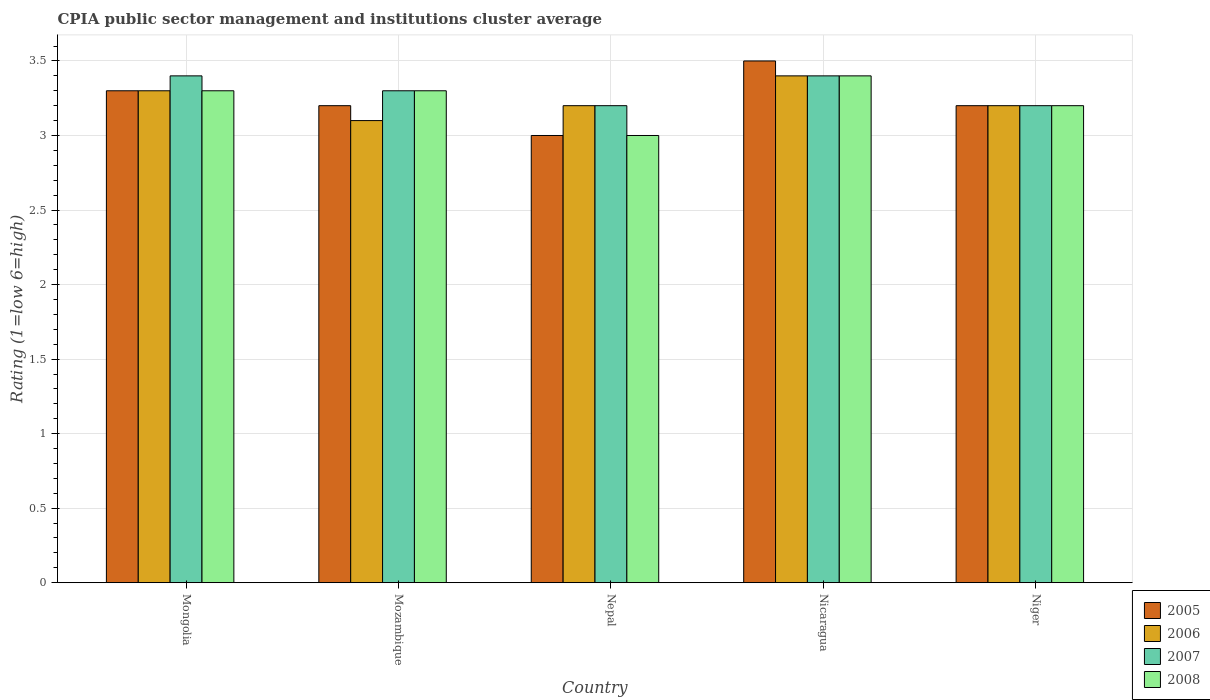Are the number of bars per tick equal to the number of legend labels?
Make the answer very short. Yes. How many bars are there on the 3rd tick from the left?
Provide a succinct answer. 4. How many bars are there on the 4th tick from the right?
Give a very brief answer. 4. What is the label of the 3rd group of bars from the left?
Your response must be concise. Nepal. What is the CPIA rating in 2008 in Mozambique?
Offer a terse response. 3.3. In which country was the CPIA rating in 2006 maximum?
Keep it short and to the point. Nicaragua. In which country was the CPIA rating in 2005 minimum?
Ensure brevity in your answer.  Nepal. What is the total CPIA rating in 2005 in the graph?
Ensure brevity in your answer.  16.2. What is the difference between the CPIA rating in 2005 in Mozambique and that in Nepal?
Offer a very short reply. 0.2. What is the difference between the CPIA rating in 2008 in Niger and the CPIA rating in 2005 in Mongolia?
Your answer should be compact. -0.1. What is the average CPIA rating in 2008 per country?
Provide a succinct answer. 3.24. What is the ratio of the CPIA rating in 2005 in Mongolia to that in Niger?
Provide a short and direct response. 1.03. Is the difference between the CPIA rating in 2008 in Mozambique and Nicaragua greater than the difference between the CPIA rating in 2007 in Mozambique and Nicaragua?
Your answer should be very brief. No. What is the difference between the highest and the second highest CPIA rating in 2008?
Offer a very short reply. -0.1. What is the difference between the highest and the lowest CPIA rating in 2006?
Offer a terse response. 0.3. In how many countries, is the CPIA rating in 2006 greater than the average CPIA rating in 2006 taken over all countries?
Offer a very short reply. 2. What does the 4th bar from the right in Niger represents?
Offer a terse response. 2005. Is it the case that in every country, the sum of the CPIA rating in 2008 and CPIA rating in 2005 is greater than the CPIA rating in 2006?
Make the answer very short. Yes. How many bars are there?
Give a very brief answer. 20. Are all the bars in the graph horizontal?
Offer a terse response. No. How many countries are there in the graph?
Your response must be concise. 5. What is the difference between two consecutive major ticks on the Y-axis?
Your answer should be very brief. 0.5. Does the graph contain any zero values?
Your answer should be compact. No. Does the graph contain grids?
Provide a succinct answer. Yes. Where does the legend appear in the graph?
Give a very brief answer. Bottom right. How many legend labels are there?
Your answer should be very brief. 4. How are the legend labels stacked?
Give a very brief answer. Vertical. What is the title of the graph?
Provide a succinct answer. CPIA public sector management and institutions cluster average. Does "2006" appear as one of the legend labels in the graph?
Offer a very short reply. Yes. What is the label or title of the Y-axis?
Your answer should be compact. Rating (1=low 6=high). What is the Rating (1=low 6=high) in 2005 in Mongolia?
Give a very brief answer. 3.3. What is the Rating (1=low 6=high) of 2006 in Mongolia?
Keep it short and to the point. 3.3. What is the Rating (1=low 6=high) in 2008 in Mongolia?
Keep it short and to the point. 3.3. What is the Rating (1=low 6=high) of 2006 in Nepal?
Provide a succinct answer. 3.2. What is the Rating (1=low 6=high) of 2007 in Nepal?
Make the answer very short. 3.2. What is the Rating (1=low 6=high) in 2005 in Nicaragua?
Your response must be concise. 3.5. What is the Rating (1=low 6=high) in 2006 in Nicaragua?
Offer a terse response. 3.4. What is the Rating (1=low 6=high) in 2007 in Nicaragua?
Your answer should be very brief. 3.4. What is the Rating (1=low 6=high) of 2008 in Nicaragua?
Make the answer very short. 3.4. What is the Rating (1=low 6=high) in 2005 in Niger?
Your answer should be very brief. 3.2. What is the Rating (1=low 6=high) in 2006 in Niger?
Provide a succinct answer. 3.2. Across all countries, what is the maximum Rating (1=low 6=high) in 2008?
Your response must be concise. 3.4. Across all countries, what is the minimum Rating (1=low 6=high) in 2005?
Provide a succinct answer. 3. Across all countries, what is the minimum Rating (1=low 6=high) in 2007?
Your response must be concise. 3.2. What is the total Rating (1=low 6=high) in 2005 in the graph?
Provide a short and direct response. 16.2. What is the total Rating (1=low 6=high) of 2007 in the graph?
Provide a succinct answer. 16.5. What is the total Rating (1=low 6=high) of 2008 in the graph?
Your answer should be compact. 16.2. What is the difference between the Rating (1=low 6=high) of 2005 in Mongolia and that in Mozambique?
Your answer should be compact. 0.1. What is the difference between the Rating (1=low 6=high) in 2006 in Mongolia and that in Mozambique?
Offer a very short reply. 0.2. What is the difference between the Rating (1=low 6=high) in 2008 in Mongolia and that in Mozambique?
Offer a terse response. 0. What is the difference between the Rating (1=low 6=high) in 2005 in Mongolia and that in Nepal?
Offer a terse response. 0.3. What is the difference between the Rating (1=low 6=high) of 2007 in Mongolia and that in Nepal?
Keep it short and to the point. 0.2. What is the difference between the Rating (1=low 6=high) of 2007 in Mongolia and that in Nicaragua?
Your response must be concise. 0. What is the difference between the Rating (1=low 6=high) in 2005 in Mongolia and that in Niger?
Ensure brevity in your answer.  0.1. What is the difference between the Rating (1=low 6=high) of 2007 in Mongolia and that in Niger?
Your response must be concise. 0.2. What is the difference between the Rating (1=low 6=high) in 2008 in Mongolia and that in Niger?
Make the answer very short. 0.1. What is the difference between the Rating (1=low 6=high) in 2005 in Mozambique and that in Nepal?
Your answer should be very brief. 0.2. What is the difference between the Rating (1=low 6=high) in 2008 in Mozambique and that in Nepal?
Make the answer very short. 0.3. What is the difference between the Rating (1=low 6=high) of 2005 in Mozambique and that in Nicaragua?
Ensure brevity in your answer.  -0.3. What is the difference between the Rating (1=low 6=high) of 2006 in Mozambique and that in Nicaragua?
Keep it short and to the point. -0.3. What is the difference between the Rating (1=low 6=high) in 2007 in Mozambique and that in Nicaragua?
Offer a terse response. -0.1. What is the difference between the Rating (1=low 6=high) in 2008 in Mozambique and that in Nicaragua?
Make the answer very short. -0.1. What is the difference between the Rating (1=low 6=high) of 2005 in Mozambique and that in Niger?
Give a very brief answer. 0. What is the difference between the Rating (1=low 6=high) in 2007 in Mozambique and that in Niger?
Your response must be concise. 0.1. What is the difference between the Rating (1=low 6=high) in 2008 in Mozambique and that in Niger?
Your answer should be very brief. 0.1. What is the difference between the Rating (1=low 6=high) in 2005 in Nepal and that in Nicaragua?
Your answer should be very brief. -0.5. What is the difference between the Rating (1=low 6=high) of 2006 in Nepal and that in Nicaragua?
Offer a terse response. -0.2. What is the difference between the Rating (1=low 6=high) in 2008 in Nepal and that in Nicaragua?
Offer a very short reply. -0.4. What is the difference between the Rating (1=low 6=high) in 2005 in Nepal and that in Niger?
Provide a succinct answer. -0.2. What is the difference between the Rating (1=low 6=high) in 2007 in Nepal and that in Niger?
Your answer should be very brief. 0. What is the difference between the Rating (1=low 6=high) in 2008 in Nepal and that in Niger?
Provide a short and direct response. -0.2. What is the difference between the Rating (1=low 6=high) of 2005 in Nicaragua and that in Niger?
Offer a terse response. 0.3. What is the difference between the Rating (1=low 6=high) of 2006 in Nicaragua and that in Niger?
Your response must be concise. 0.2. What is the difference between the Rating (1=low 6=high) in 2008 in Nicaragua and that in Niger?
Keep it short and to the point. 0.2. What is the difference between the Rating (1=low 6=high) in 2005 in Mongolia and the Rating (1=low 6=high) in 2006 in Mozambique?
Your answer should be very brief. 0.2. What is the difference between the Rating (1=low 6=high) of 2005 in Mongolia and the Rating (1=low 6=high) of 2008 in Mozambique?
Give a very brief answer. 0. What is the difference between the Rating (1=low 6=high) of 2006 in Mongolia and the Rating (1=low 6=high) of 2007 in Mozambique?
Offer a terse response. 0. What is the difference between the Rating (1=low 6=high) of 2006 in Mongolia and the Rating (1=low 6=high) of 2008 in Mozambique?
Provide a succinct answer. 0. What is the difference between the Rating (1=low 6=high) in 2005 in Mongolia and the Rating (1=low 6=high) in 2006 in Nepal?
Provide a short and direct response. 0.1. What is the difference between the Rating (1=low 6=high) of 2005 in Mongolia and the Rating (1=low 6=high) of 2007 in Nepal?
Provide a succinct answer. 0.1. What is the difference between the Rating (1=low 6=high) in 2005 in Mongolia and the Rating (1=low 6=high) in 2008 in Nepal?
Ensure brevity in your answer.  0.3. What is the difference between the Rating (1=low 6=high) in 2006 in Mongolia and the Rating (1=low 6=high) in 2007 in Nepal?
Offer a very short reply. 0.1. What is the difference between the Rating (1=low 6=high) of 2006 in Mongolia and the Rating (1=low 6=high) of 2008 in Nepal?
Make the answer very short. 0.3. What is the difference between the Rating (1=low 6=high) in 2007 in Mongolia and the Rating (1=low 6=high) in 2008 in Nepal?
Offer a very short reply. 0.4. What is the difference between the Rating (1=low 6=high) in 2005 in Mongolia and the Rating (1=low 6=high) in 2006 in Nicaragua?
Your answer should be compact. -0.1. What is the difference between the Rating (1=low 6=high) in 2005 in Mongolia and the Rating (1=low 6=high) in 2007 in Nicaragua?
Your answer should be very brief. -0.1. What is the difference between the Rating (1=low 6=high) of 2006 in Mongolia and the Rating (1=low 6=high) of 2007 in Nicaragua?
Your answer should be compact. -0.1. What is the difference between the Rating (1=low 6=high) of 2007 in Mongolia and the Rating (1=low 6=high) of 2008 in Nicaragua?
Make the answer very short. 0. What is the difference between the Rating (1=low 6=high) of 2005 in Mongolia and the Rating (1=low 6=high) of 2006 in Niger?
Provide a short and direct response. 0.1. What is the difference between the Rating (1=low 6=high) in 2005 in Mongolia and the Rating (1=low 6=high) in 2008 in Niger?
Provide a succinct answer. 0.1. What is the difference between the Rating (1=low 6=high) of 2006 in Mongolia and the Rating (1=low 6=high) of 2007 in Niger?
Your response must be concise. 0.1. What is the difference between the Rating (1=low 6=high) in 2006 in Mongolia and the Rating (1=low 6=high) in 2008 in Niger?
Give a very brief answer. 0.1. What is the difference between the Rating (1=low 6=high) in 2007 in Mongolia and the Rating (1=low 6=high) in 2008 in Niger?
Ensure brevity in your answer.  0.2. What is the difference between the Rating (1=low 6=high) of 2005 in Mozambique and the Rating (1=low 6=high) of 2006 in Nepal?
Give a very brief answer. 0. What is the difference between the Rating (1=low 6=high) in 2005 in Mozambique and the Rating (1=low 6=high) in 2007 in Nepal?
Your answer should be very brief. 0. What is the difference between the Rating (1=low 6=high) of 2006 in Mozambique and the Rating (1=low 6=high) of 2007 in Nepal?
Give a very brief answer. -0.1. What is the difference between the Rating (1=low 6=high) in 2006 in Mozambique and the Rating (1=low 6=high) in 2008 in Nepal?
Your response must be concise. 0.1. What is the difference between the Rating (1=low 6=high) of 2005 in Mozambique and the Rating (1=low 6=high) of 2007 in Nicaragua?
Ensure brevity in your answer.  -0.2. What is the difference between the Rating (1=low 6=high) of 2005 in Mozambique and the Rating (1=low 6=high) of 2008 in Nicaragua?
Offer a very short reply. -0.2. What is the difference between the Rating (1=low 6=high) in 2006 in Mozambique and the Rating (1=low 6=high) in 2007 in Nicaragua?
Keep it short and to the point. -0.3. What is the difference between the Rating (1=low 6=high) in 2006 in Mozambique and the Rating (1=low 6=high) in 2008 in Nicaragua?
Offer a very short reply. -0.3. What is the difference between the Rating (1=low 6=high) of 2005 in Mozambique and the Rating (1=low 6=high) of 2007 in Niger?
Offer a terse response. 0. What is the difference between the Rating (1=low 6=high) in 2005 in Mozambique and the Rating (1=low 6=high) in 2008 in Niger?
Your response must be concise. 0. What is the difference between the Rating (1=low 6=high) in 2006 in Mozambique and the Rating (1=low 6=high) in 2007 in Niger?
Offer a very short reply. -0.1. What is the difference between the Rating (1=low 6=high) of 2006 in Mozambique and the Rating (1=low 6=high) of 2008 in Niger?
Make the answer very short. -0.1. What is the difference between the Rating (1=low 6=high) of 2007 in Mozambique and the Rating (1=low 6=high) of 2008 in Niger?
Your answer should be compact. 0.1. What is the difference between the Rating (1=low 6=high) in 2005 in Nepal and the Rating (1=low 6=high) in 2006 in Nicaragua?
Provide a short and direct response. -0.4. What is the difference between the Rating (1=low 6=high) in 2005 in Nepal and the Rating (1=low 6=high) in 2008 in Nicaragua?
Ensure brevity in your answer.  -0.4. What is the difference between the Rating (1=low 6=high) of 2006 in Nepal and the Rating (1=low 6=high) of 2007 in Nicaragua?
Give a very brief answer. -0.2. What is the difference between the Rating (1=low 6=high) in 2006 in Nepal and the Rating (1=low 6=high) in 2008 in Nicaragua?
Your answer should be compact. -0.2. What is the difference between the Rating (1=low 6=high) in 2005 in Nepal and the Rating (1=low 6=high) in 2006 in Niger?
Your answer should be compact. -0.2. What is the difference between the Rating (1=low 6=high) of 2006 in Nepal and the Rating (1=low 6=high) of 2008 in Niger?
Your answer should be very brief. 0. What is the difference between the Rating (1=low 6=high) of 2007 in Nepal and the Rating (1=low 6=high) of 2008 in Niger?
Offer a very short reply. 0. What is the difference between the Rating (1=low 6=high) in 2005 in Nicaragua and the Rating (1=low 6=high) in 2008 in Niger?
Provide a succinct answer. 0.3. What is the difference between the Rating (1=low 6=high) of 2006 in Nicaragua and the Rating (1=low 6=high) of 2007 in Niger?
Make the answer very short. 0.2. What is the difference between the Rating (1=low 6=high) of 2006 in Nicaragua and the Rating (1=low 6=high) of 2008 in Niger?
Your answer should be compact. 0.2. What is the difference between the Rating (1=low 6=high) of 2007 in Nicaragua and the Rating (1=low 6=high) of 2008 in Niger?
Your answer should be compact. 0.2. What is the average Rating (1=low 6=high) of 2005 per country?
Ensure brevity in your answer.  3.24. What is the average Rating (1=low 6=high) in 2006 per country?
Give a very brief answer. 3.24. What is the average Rating (1=low 6=high) of 2007 per country?
Provide a succinct answer. 3.3. What is the average Rating (1=low 6=high) in 2008 per country?
Make the answer very short. 3.24. What is the difference between the Rating (1=low 6=high) of 2005 and Rating (1=low 6=high) of 2006 in Mongolia?
Make the answer very short. 0. What is the difference between the Rating (1=low 6=high) in 2005 and Rating (1=low 6=high) in 2007 in Mongolia?
Make the answer very short. -0.1. What is the difference between the Rating (1=low 6=high) in 2006 and Rating (1=low 6=high) in 2008 in Mongolia?
Your response must be concise. 0. What is the difference between the Rating (1=low 6=high) in 2007 and Rating (1=low 6=high) in 2008 in Mongolia?
Your answer should be compact. 0.1. What is the difference between the Rating (1=low 6=high) in 2005 and Rating (1=low 6=high) in 2008 in Mozambique?
Provide a succinct answer. -0.1. What is the difference between the Rating (1=low 6=high) of 2006 and Rating (1=low 6=high) of 2007 in Mozambique?
Offer a terse response. -0.2. What is the difference between the Rating (1=low 6=high) of 2007 and Rating (1=low 6=high) of 2008 in Mozambique?
Provide a succinct answer. 0. What is the difference between the Rating (1=low 6=high) in 2006 and Rating (1=low 6=high) in 2007 in Nepal?
Give a very brief answer. 0. What is the difference between the Rating (1=low 6=high) of 2006 and Rating (1=low 6=high) of 2008 in Nepal?
Ensure brevity in your answer.  0.2. What is the difference between the Rating (1=low 6=high) of 2005 and Rating (1=low 6=high) of 2008 in Nicaragua?
Make the answer very short. 0.1. What is the difference between the Rating (1=low 6=high) in 2006 and Rating (1=low 6=high) in 2008 in Nicaragua?
Offer a very short reply. 0. What is the difference between the Rating (1=low 6=high) of 2007 and Rating (1=low 6=high) of 2008 in Nicaragua?
Your response must be concise. 0. What is the difference between the Rating (1=low 6=high) in 2005 and Rating (1=low 6=high) in 2007 in Niger?
Your answer should be very brief. 0. What is the difference between the Rating (1=low 6=high) in 2006 and Rating (1=low 6=high) in 2007 in Niger?
Your answer should be compact. 0. What is the difference between the Rating (1=low 6=high) of 2007 and Rating (1=low 6=high) of 2008 in Niger?
Your answer should be compact. 0. What is the ratio of the Rating (1=low 6=high) of 2005 in Mongolia to that in Mozambique?
Your answer should be very brief. 1.03. What is the ratio of the Rating (1=low 6=high) of 2006 in Mongolia to that in Mozambique?
Your response must be concise. 1.06. What is the ratio of the Rating (1=low 6=high) in 2007 in Mongolia to that in Mozambique?
Provide a succinct answer. 1.03. What is the ratio of the Rating (1=low 6=high) of 2006 in Mongolia to that in Nepal?
Provide a succinct answer. 1.03. What is the ratio of the Rating (1=low 6=high) in 2005 in Mongolia to that in Nicaragua?
Your answer should be very brief. 0.94. What is the ratio of the Rating (1=low 6=high) of 2006 in Mongolia to that in Nicaragua?
Offer a very short reply. 0.97. What is the ratio of the Rating (1=low 6=high) of 2007 in Mongolia to that in Nicaragua?
Make the answer very short. 1. What is the ratio of the Rating (1=low 6=high) of 2008 in Mongolia to that in Nicaragua?
Your response must be concise. 0.97. What is the ratio of the Rating (1=low 6=high) in 2005 in Mongolia to that in Niger?
Make the answer very short. 1.03. What is the ratio of the Rating (1=low 6=high) in 2006 in Mongolia to that in Niger?
Your answer should be compact. 1.03. What is the ratio of the Rating (1=low 6=high) of 2007 in Mongolia to that in Niger?
Offer a very short reply. 1.06. What is the ratio of the Rating (1=low 6=high) in 2008 in Mongolia to that in Niger?
Your answer should be compact. 1.03. What is the ratio of the Rating (1=low 6=high) in 2005 in Mozambique to that in Nepal?
Provide a short and direct response. 1.07. What is the ratio of the Rating (1=low 6=high) of 2006 in Mozambique to that in Nepal?
Ensure brevity in your answer.  0.97. What is the ratio of the Rating (1=low 6=high) of 2007 in Mozambique to that in Nepal?
Provide a succinct answer. 1.03. What is the ratio of the Rating (1=low 6=high) of 2005 in Mozambique to that in Nicaragua?
Provide a succinct answer. 0.91. What is the ratio of the Rating (1=low 6=high) in 2006 in Mozambique to that in Nicaragua?
Your response must be concise. 0.91. What is the ratio of the Rating (1=low 6=high) of 2007 in Mozambique to that in Nicaragua?
Ensure brevity in your answer.  0.97. What is the ratio of the Rating (1=low 6=high) in 2008 in Mozambique to that in Nicaragua?
Your response must be concise. 0.97. What is the ratio of the Rating (1=low 6=high) of 2005 in Mozambique to that in Niger?
Ensure brevity in your answer.  1. What is the ratio of the Rating (1=low 6=high) of 2006 in Mozambique to that in Niger?
Offer a terse response. 0.97. What is the ratio of the Rating (1=low 6=high) of 2007 in Mozambique to that in Niger?
Provide a short and direct response. 1.03. What is the ratio of the Rating (1=low 6=high) in 2008 in Mozambique to that in Niger?
Make the answer very short. 1.03. What is the ratio of the Rating (1=low 6=high) in 2005 in Nepal to that in Nicaragua?
Give a very brief answer. 0.86. What is the ratio of the Rating (1=low 6=high) of 2008 in Nepal to that in Nicaragua?
Offer a terse response. 0.88. What is the ratio of the Rating (1=low 6=high) in 2005 in Nepal to that in Niger?
Provide a short and direct response. 0.94. What is the ratio of the Rating (1=low 6=high) in 2006 in Nepal to that in Niger?
Keep it short and to the point. 1. What is the ratio of the Rating (1=low 6=high) in 2005 in Nicaragua to that in Niger?
Provide a succinct answer. 1.09. What is the ratio of the Rating (1=low 6=high) in 2007 in Nicaragua to that in Niger?
Your response must be concise. 1.06. What is the difference between the highest and the second highest Rating (1=low 6=high) in 2005?
Provide a succinct answer. 0.2. What is the difference between the highest and the second highest Rating (1=low 6=high) in 2007?
Give a very brief answer. 0. What is the difference between the highest and the second highest Rating (1=low 6=high) of 2008?
Make the answer very short. 0.1. What is the difference between the highest and the lowest Rating (1=low 6=high) of 2005?
Keep it short and to the point. 0.5. What is the difference between the highest and the lowest Rating (1=low 6=high) of 2006?
Provide a succinct answer. 0.3. What is the difference between the highest and the lowest Rating (1=low 6=high) of 2008?
Your response must be concise. 0.4. 